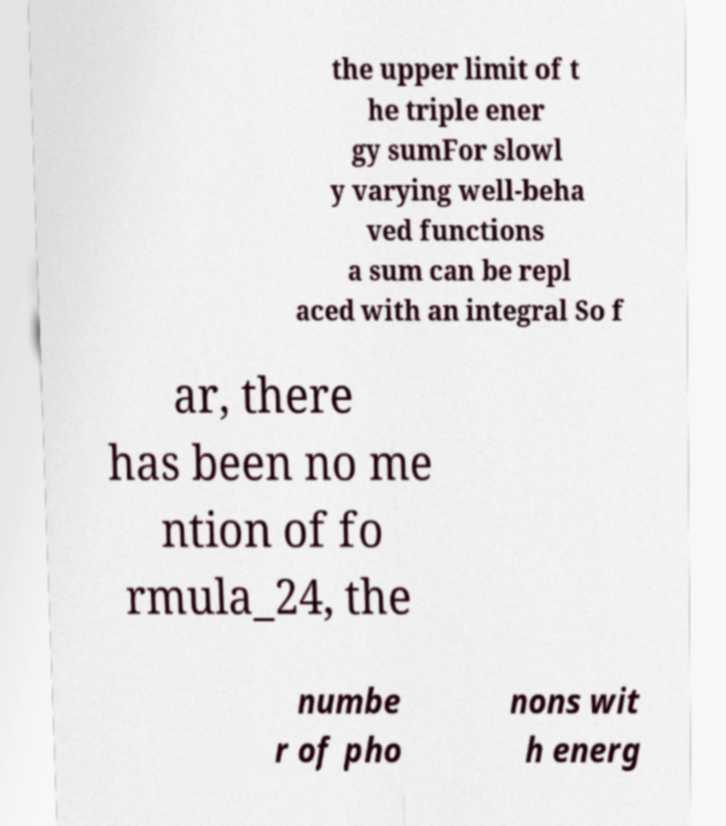What messages or text are displayed in this image? I need them in a readable, typed format. the upper limit of t he triple ener gy sumFor slowl y varying well-beha ved functions a sum can be repl aced with an integral So f ar, there has been no me ntion of fo rmula_24, the numbe r of pho nons wit h energ 